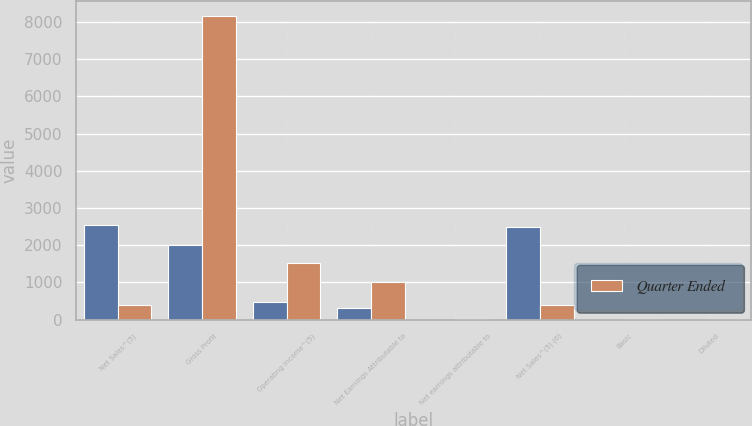Convert chart to OTSL. <chart><loc_0><loc_0><loc_500><loc_500><stacked_bar_chart><ecel><fcel>Net Sales^(5)<fcel>Gross Profit<fcel>Operating Income^(5)<fcel>Net Earnings Attributable to<fcel>Net earnings attributable to<fcel>Net Sales^(5) (6)<fcel>Basic<fcel>Diluted<nl><fcel>nan<fcel>2549.5<fcel>2010.3<fcel>482<fcel>299.5<fcel>0.77<fcel>2476.7<fcel>0.71<fcel>0.7<nl><fcel>Quarter Ended<fcel>390.75<fcel>8155.8<fcel>1526<fcel>1019.8<fcel>2.63<fcel>390.75<fcel>2.2<fcel>2.16<nl></chart> 